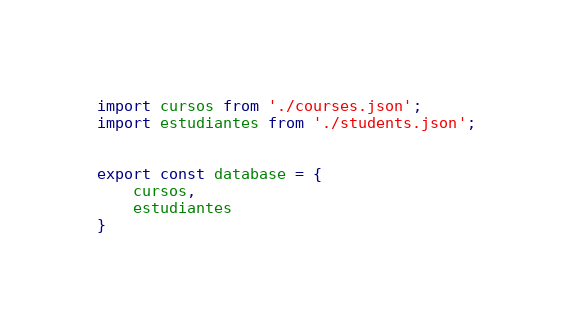<code> <loc_0><loc_0><loc_500><loc_500><_TypeScript_>import cursos from './courses.json';
import estudiantes from './students.json';


export const database = {
    cursos,
    estudiantes
}</code> 